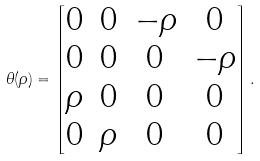Convert formula to latex. <formula><loc_0><loc_0><loc_500><loc_500>\theta ( \rho ) = \begin{bmatrix} 0 & 0 & - \rho & 0 \\ 0 & 0 & 0 & - \rho \\ \rho & 0 & 0 & 0 \\ 0 & \rho & 0 & 0 \end{bmatrix} .</formula> 